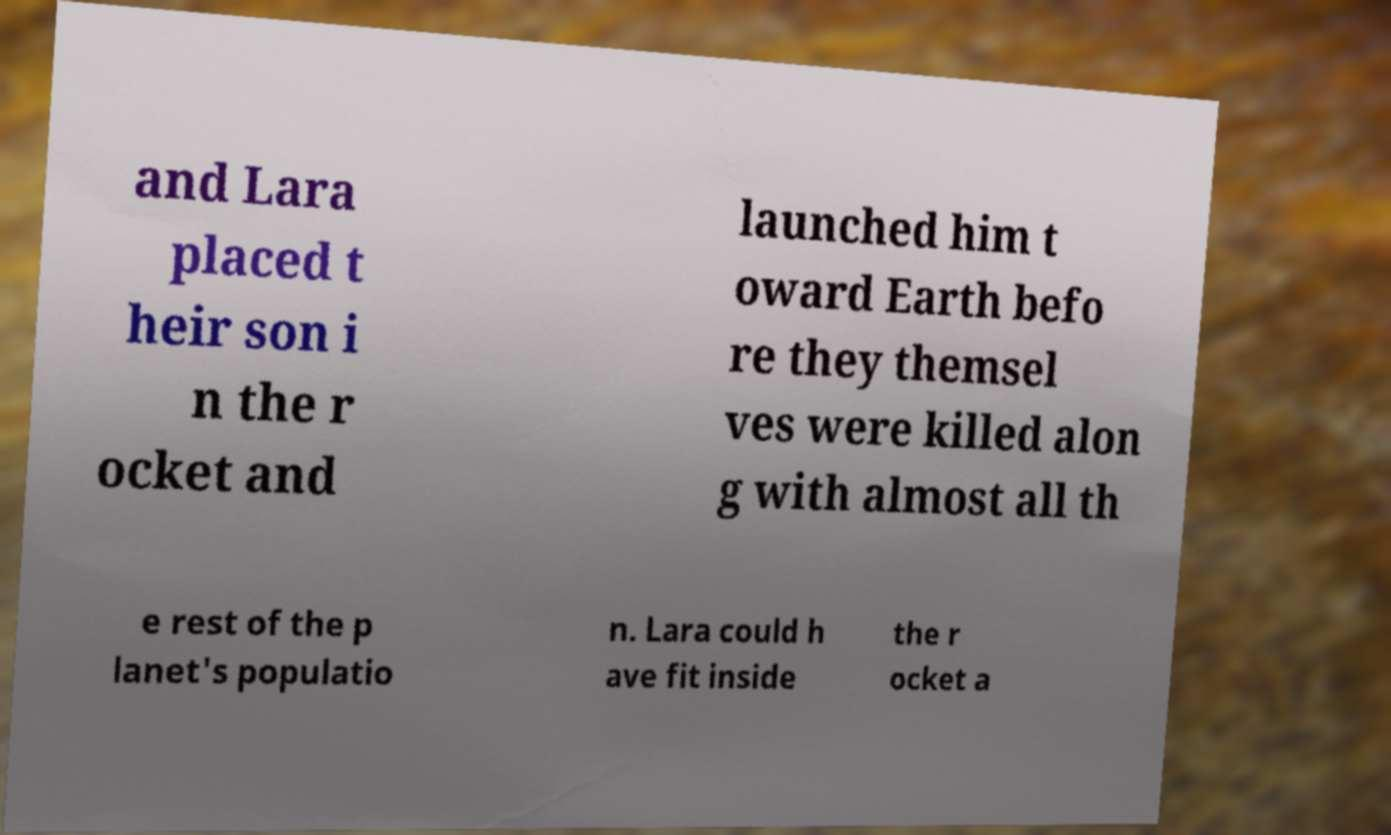Can you accurately transcribe the text from the provided image for me? and Lara placed t heir son i n the r ocket and launched him t oward Earth befo re they themsel ves were killed alon g with almost all th e rest of the p lanet's populatio n. Lara could h ave fit inside the r ocket a 